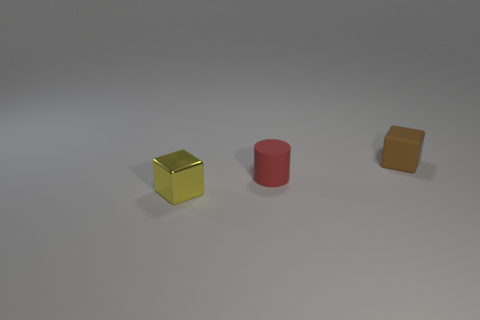Add 1 blue shiny objects. How many objects exist? 4 Subtract all yellow cubes. How many cubes are left? 1 Subtract all blocks. How many objects are left? 1 Subtract all purple cylinders. Subtract all gray blocks. How many cylinders are left? 1 Subtract all shiny blocks. Subtract all small rubber cylinders. How many objects are left? 1 Add 3 yellow cubes. How many yellow cubes are left? 4 Add 3 big gray balls. How many big gray balls exist? 3 Subtract 0 gray spheres. How many objects are left? 3 